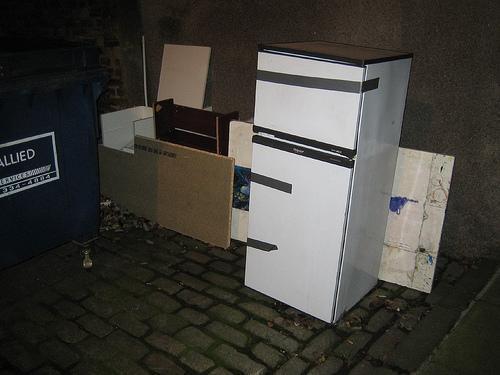How many refrigerators are shown?
Give a very brief answer. 1. 